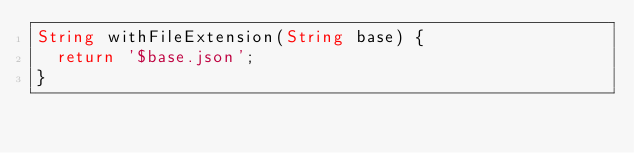<code> <loc_0><loc_0><loc_500><loc_500><_Dart_>String withFileExtension(String base) {
  return '$base.json';
}
</code> 